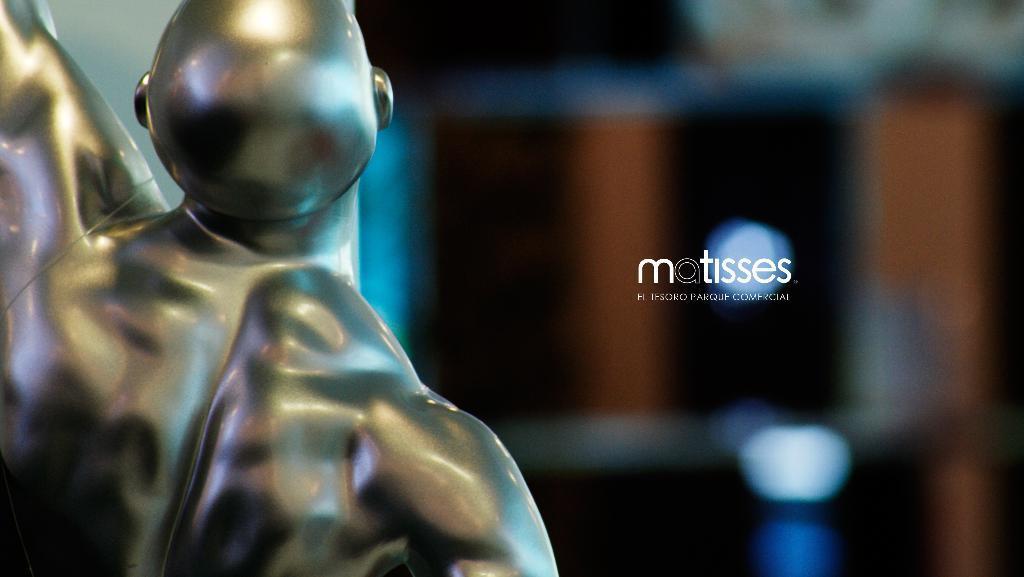Can you describe this image briefly? In the picture I can see the sculpture on the left side of the image and the right side of the image is blurred. Here I can see the watermark in the center of the image. 